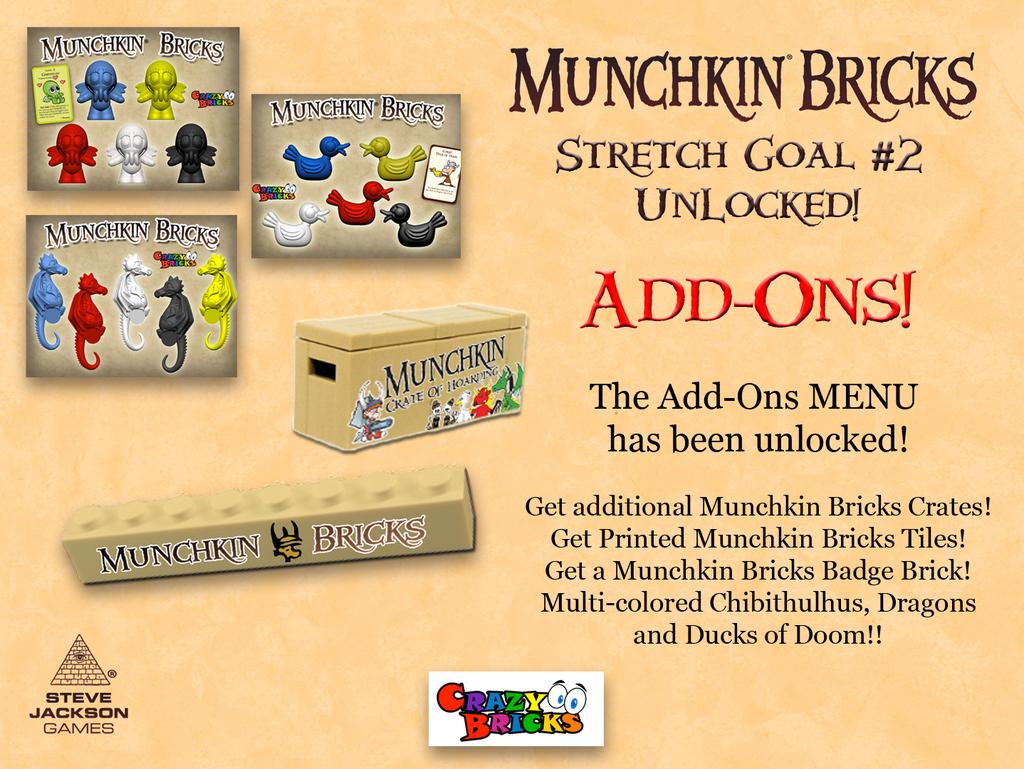What kind of bricks are featured?
Offer a terse response. Munchkin. What goal number is this?
Keep it short and to the point. 2. 